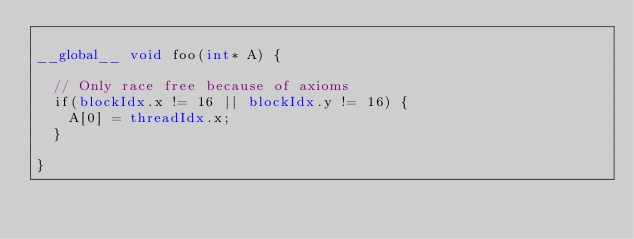<code> <loc_0><loc_0><loc_500><loc_500><_Cuda_>
__global__ void foo(int* A) {

  // Only race free because of axioms
  if(blockIdx.x != 16 || blockIdx.y != 16) {
    A[0] = threadIdx.x;
  }

}
</code> 